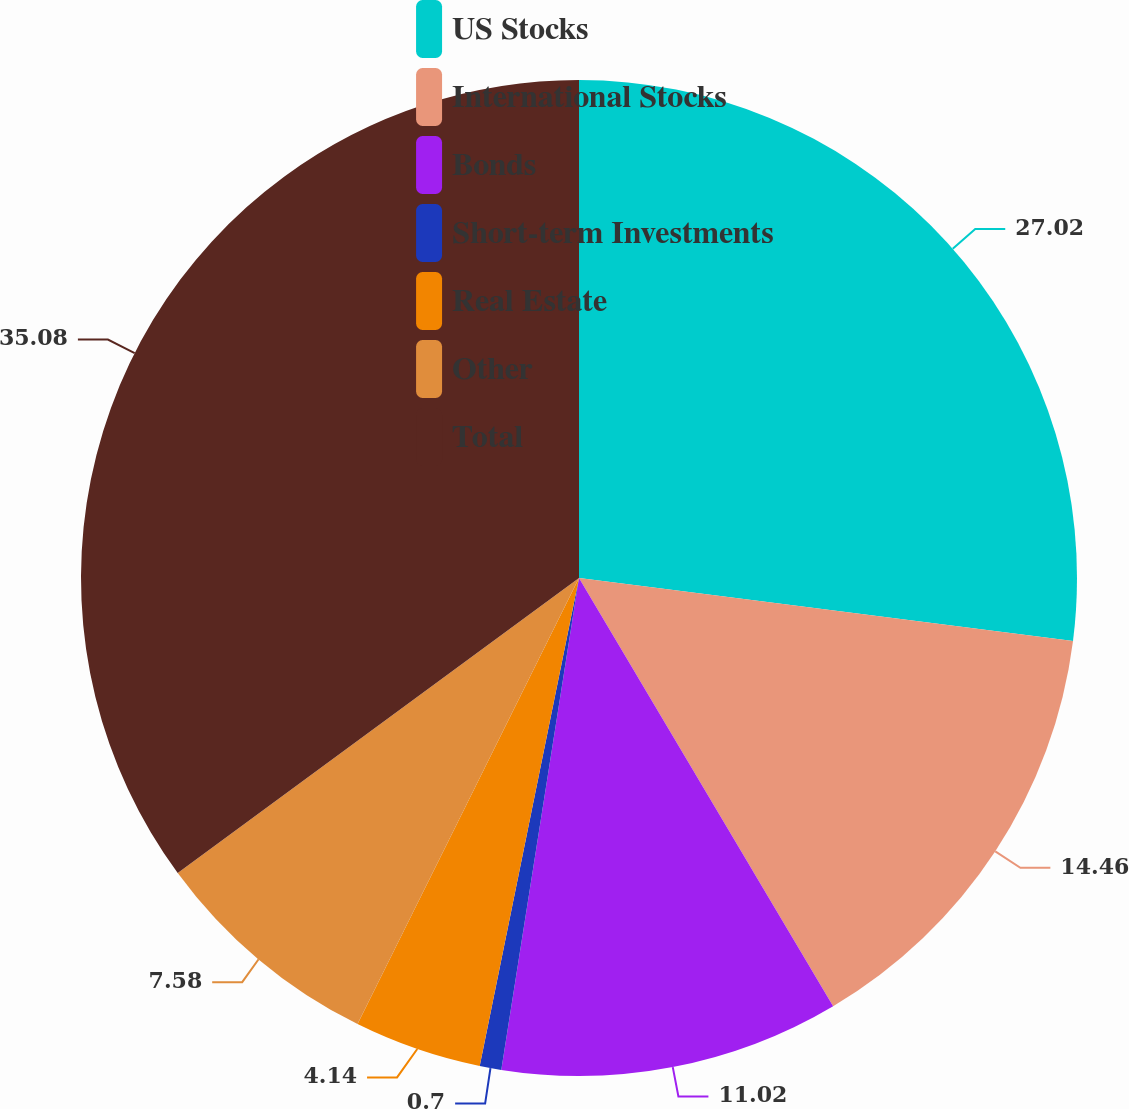<chart> <loc_0><loc_0><loc_500><loc_500><pie_chart><fcel>US Stocks<fcel>International Stocks<fcel>Bonds<fcel>Short-term Investments<fcel>Real Estate<fcel>Other<fcel>Total<nl><fcel>27.02%<fcel>14.46%<fcel>11.02%<fcel>0.7%<fcel>4.14%<fcel>7.58%<fcel>35.09%<nl></chart> 